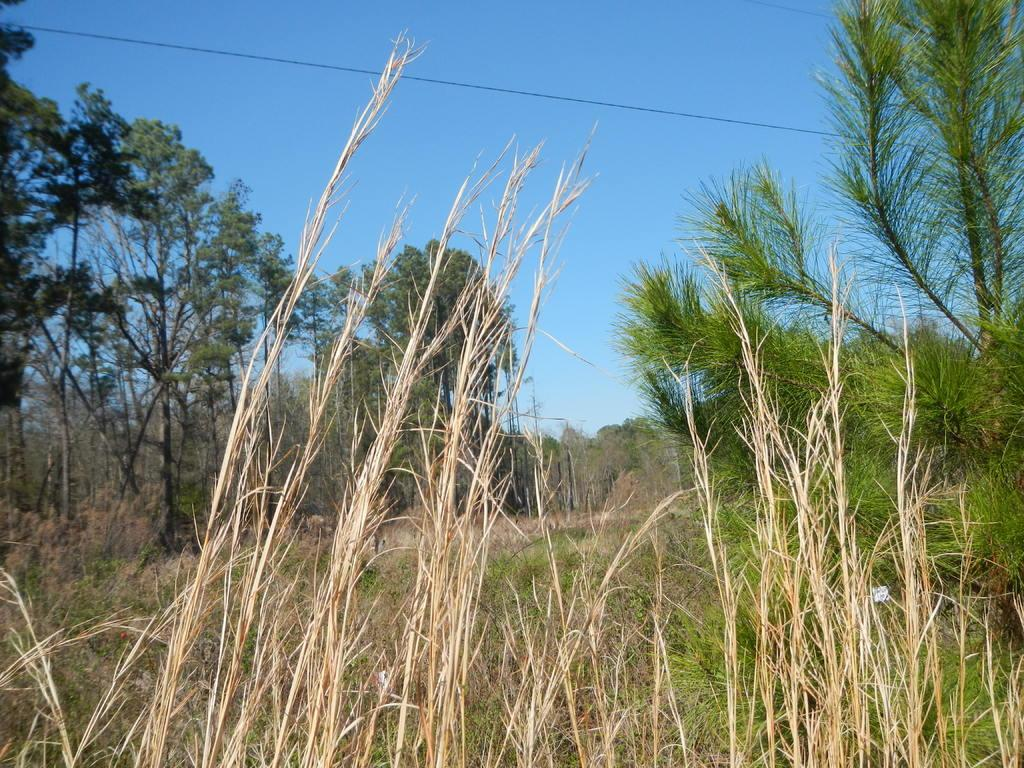What type of vegetation can be seen in the image? Plants, grass, and trees can be seen in the image. What part of the natural environment is visible in the image? The sky is visible in the image. What type of store can be seen in the image? There is no store present in the image; it features plants, grass, trees, and the sky. What time of day is depicted in the image? The time of day cannot be determined from the image, as there are no specific indicators of time. 